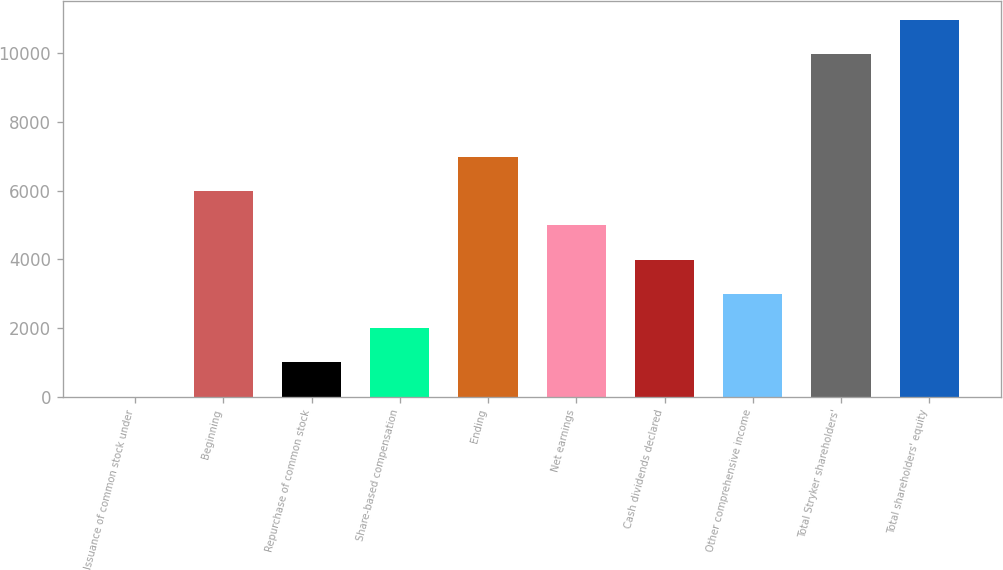Convert chart to OTSL. <chart><loc_0><loc_0><loc_500><loc_500><bar_chart><fcel>Issuance of common stock under<fcel>Beginning<fcel>Repurchase of common stock<fcel>Share-based compensation<fcel>Ending<fcel>Net earnings<fcel>Cash dividends declared<fcel>Other comprehensive income<fcel>Total Stryker shareholders'<fcel>Total shareholders' equity<nl><fcel>1.7<fcel>5988.68<fcel>999.53<fcel>1997.36<fcel>6986.51<fcel>4990.85<fcel>3993.02<fcel>2995.19<fcel>9966<fcel>10963.8<nl></chart> 